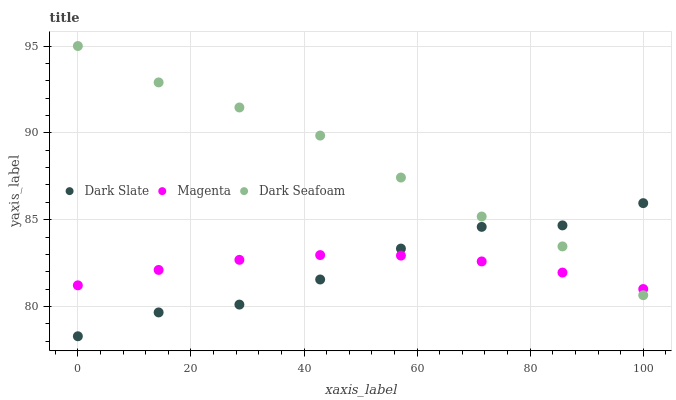Does Dark Slate have the minimum area under the curve?
Answer yes or no. Yes. Does Dark Seafoam have the maximum area under the curve?
Answer yes or no. Yes. Does Magenta have the minimum area under the curve?
Answer yes or no. No. Does Magenta have the maximum area under the curve?
Answer yes or no. No. Is Magenta the smoothest?
Answer yes or no. Yes. Is Dark Slate the roughest?
Answer yes or no. Yes. Is Dark Seafoam the smoothest?
Answer yes or no. No. Is Dark Seafoam the roughest?
Answer yes or no. No. Does Dark Slate have the lowest value?
Answer yes or no. Yes. Does Dark Seafoam have the lowest value?
Answer yes or no. No. Does Dark Seafoam have the highest value?
Answer yes or no. Yes. Does Magenta have the highest value?
Answer yes or no. No. Does Dark Slate intersect Dark Seafoam?
Answer yes or no. Yes. Is Dark Slate less than Dark Seafoam?
Answer yes or no. No. Is Dark Slate greater than Dark Seafoam?
Answer yes or no. No. 